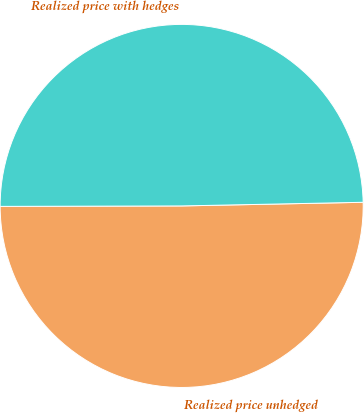<chart> <loc_0><loc_0><loc_500><loc_500><pie_chart><fcel>Realized price unhedged<fcel>Realized price with hedges<nl><fcel>50.28%<fcel>49.72%<nl></chart> 